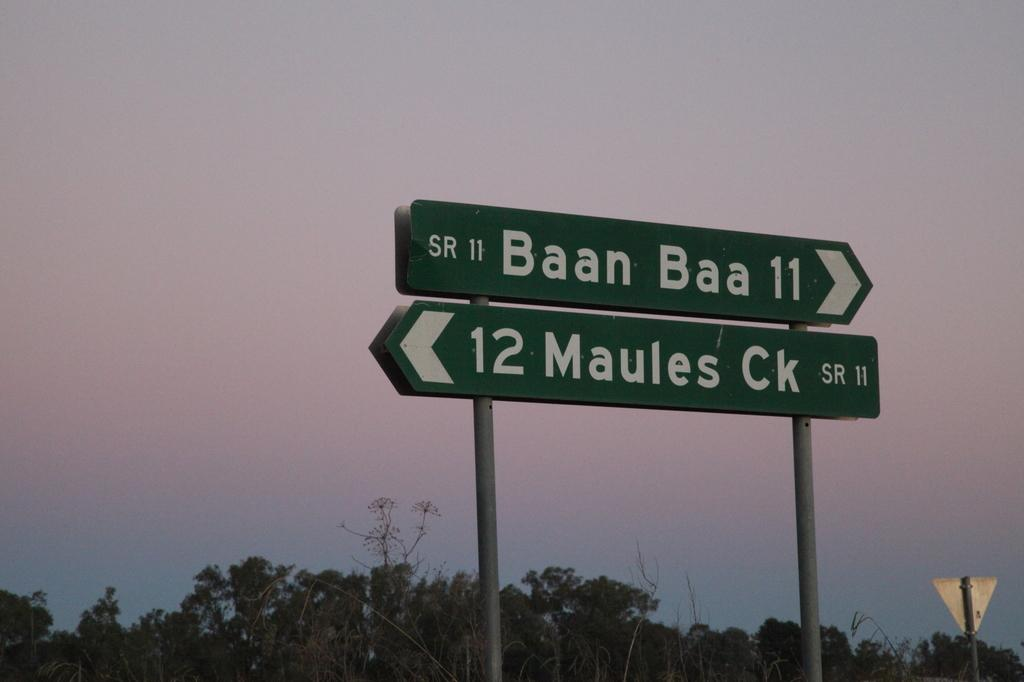<image>
Give a short and clear explanation of the subsequent image. a baan baa 11 sign with 12 maules ck under 